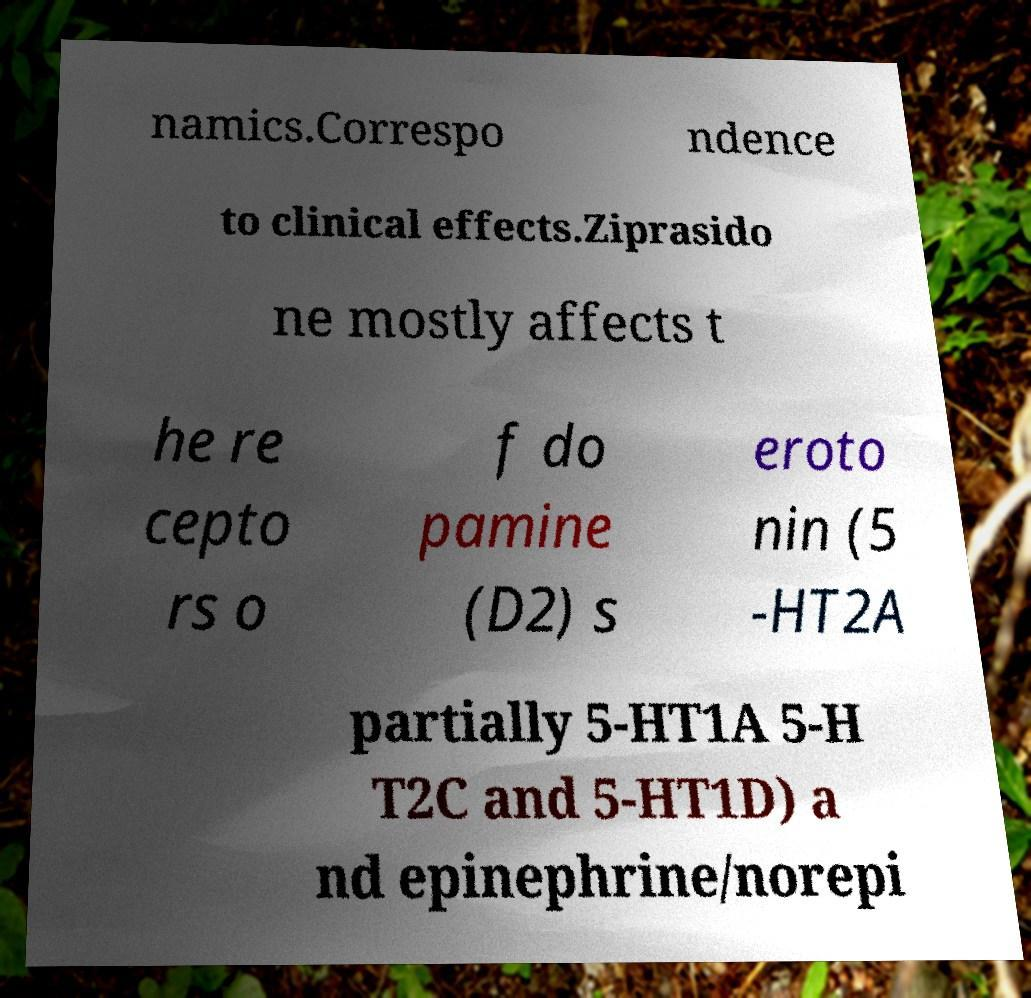Can you accurately transcribe the text from the provided image for me? namics.Correspo ndence to clinical effects.Ziprasido ne mostly affects t he re cepto rs o f do pamine (D2) s eroto nin (5 -HT2A partially 5-HT1A 5-H T2C and 5-HT1D) a nd epinephrine/norepi 